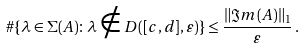<formula> <loc_0><loc_0><loc_500><loc_500>\# \{ \lambda \in \Sigma ( A ) \colon \lambda \notin D ( [ c , d ] , \varepsilon ) \} \leq \frac { \| \Im m ( A ) \| _ { 1 } } { \varepsilon } \, .</formula> 